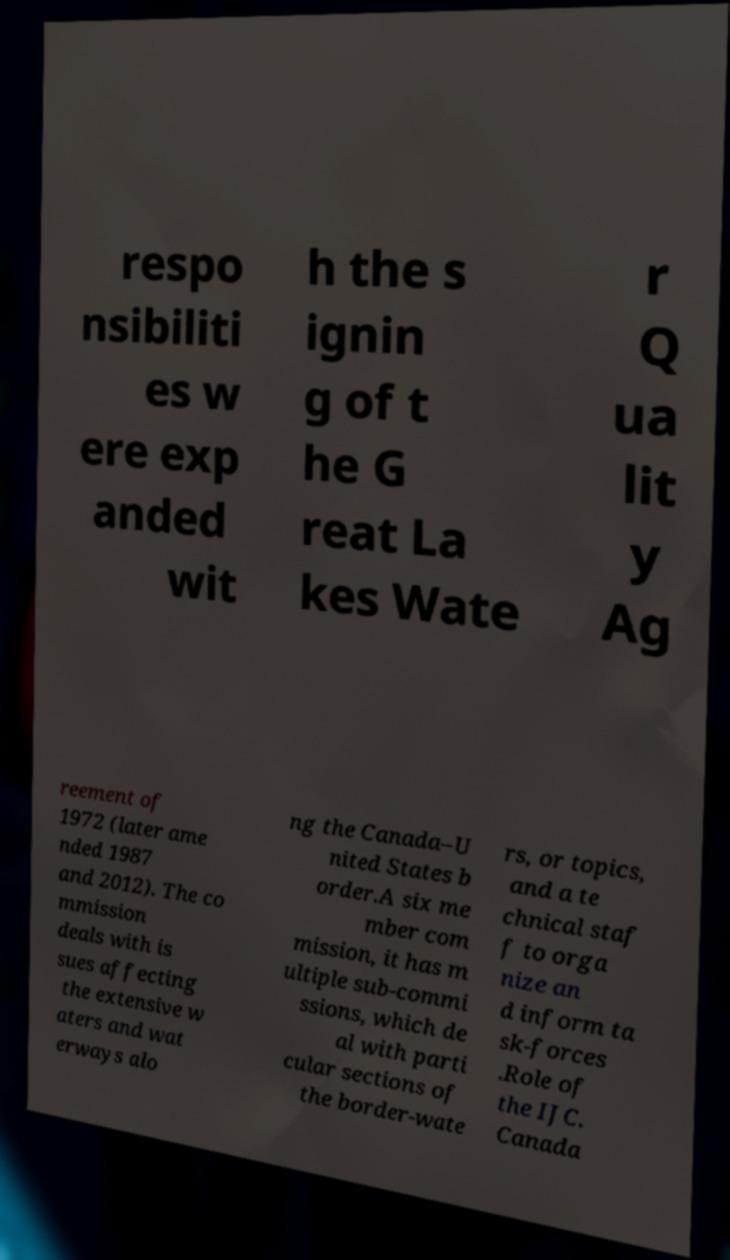What messages or text are displayed in this image? I need them in a readable, typed format. respo nsibiliti es w ere exp anded wit h the s ignin g of t he G reat La kes Wate r Q ua lit y Ag reement of 1972 (later ame nded 1987 and 2012). The co mmission deals with is sues affecting the extensive w aters and wat erways alo ng the Canada–U nited States b order.A six me mber com mission, it has m ultiple sub-commi ssions, which de al with parti cular sections of the border-wate rs, or topics, and a te chnical staf f to orga nize an d inform ta sk-forces .Role of the IJC. Canada 